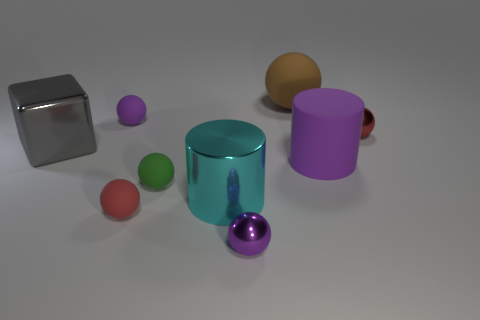Subtract all tiny green rubber balls. How many balls are left? 5 Add 1 large cyan rubber cubes. How many objects exist? 10 Subtract all balls. How many objects are left? 3 Subtract 1 cubes. How many cubes are left? 0 Subtract all gray cylinders. Subtract all blue blocks. How many cylinders are left? 2 Subtract all yellow spheres. How many purple cylinders are left? 1 Subtract all large purple matte cylinders. Subtract all gray cubes. How many objects are left? 7 Add 1 purple balls. How many purple balls are left? 3 Add 2 purple metallic cubes. How many purple metallic cubes exist? 2 Subtract all purple cylinders. How many cylinders are left? 1 